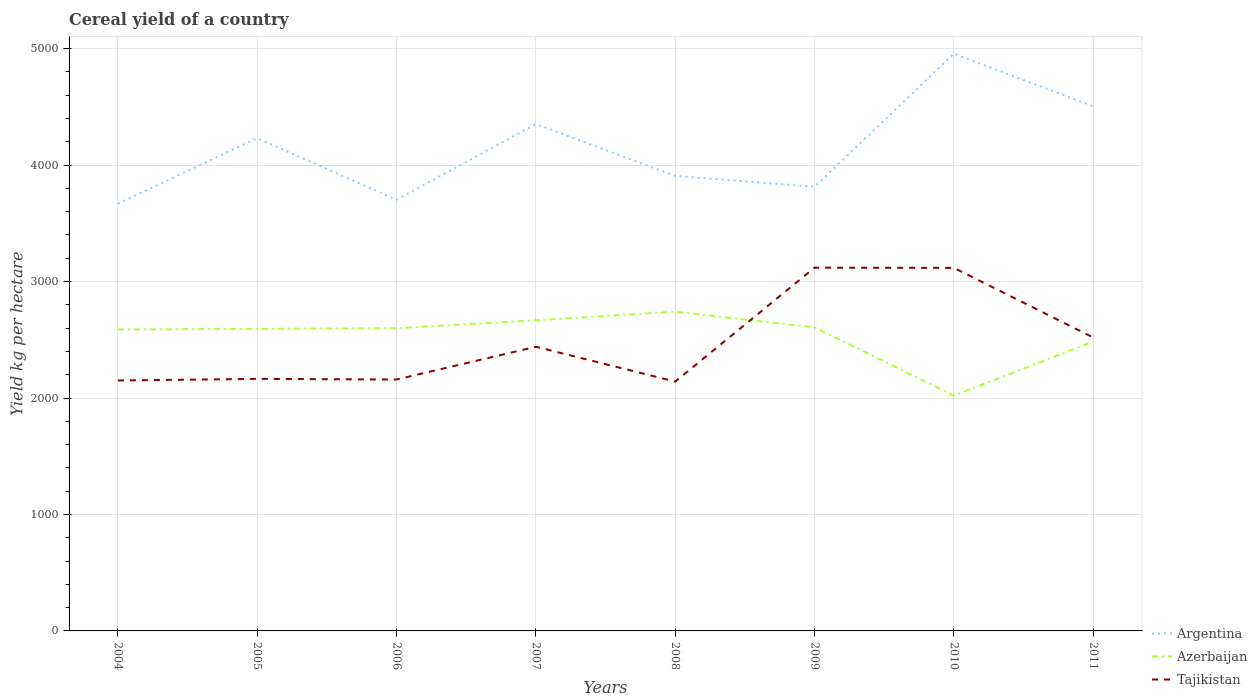How many different coloured lines are there?
Ensure brevity in your answer.  3. Does the line corresponding to Azerbaijan intersect with the line corresponding to Tajikistan?
Keep it short and to the point. Yes. Is the number of lines equal to the number of legend labels?
Your answer should be very brief. Yes. Across all years, what is the maximum total cereal yield in Argentina?
Provide a short and direct response. 3668.39. In which year was the total cereal yield in Argentina maximum?
Provide a short and direct response. 2004. What is the total total cereal yield in Argentina in the graph?
Your answer should be very brief. -649.98. What is the difference between the highest and the second highest total cereal yield in Azerbaijan?
Offer a terse response. 720.84. Are the values on the major ticks of Y-axis written in scientific E-notation?
Your response must be concise. No. Does the graph contain any zero values?
Ensure brevity in your answer.  No. Where does the legend appear in the graph?
Offer a very short reply. Bottom right. How are the legend labels stacked?
Offer a very short reply. Vertical. What is the title of the graph?
Offer a terse response. Cereal yield of a country. Does "Thailand" appear as one of the legend labels in the graph?
Make the answer very short. No. What is the label or title of the X-axis?
Offer a very short reply. Years. What is the label or title of the Y-axis?
Your answer should be compact. Yield kg per hectare. What is the Yield kg per hectare of Argentina in 2004?
Your answer should be very brief. 3668.39. What is the Yield kg per hectare of Azerbaijan in 2004?
Keep it short and to the point. 2588.77. What is the Yield kg per hectare of Tajikistan in 2004?
Make the answer very short. 2150.44. What is the Yield kg per hectare in Argentina in 2005?
Your answer should be very brief. 4231.04. What is the Yield kg per hectare of Azerbaijan in 2005?
Make the answer very short. 2593.13. What is the Yield kg per hectare of Tajikistan in 2005?
Provide a succinct answer. 2164.4. What is the Yield kg per hectare of Argentina in 2006?
Offer a very short reply. 3702.29. What is the Yield kg per hectare of Azerbaijan in 2006?
Make the answer very short. 2599.35. What is the Yield kg per hectare in Tajikistan in 2006?
Offer a very short reply. 2158.71. What is the Yield kg per hectare of Argentina in 2007?
Keep it short and to the point. 4352.27. What is the Yield kg per hectare in Azerbaijan in 2007?
Your response must be concise. 2667.4. What is the Yield kg per hectare of Tajikistan in 2007?
Give a very brief answer. 2440.03. What is the Yield kg per hectare of Argentina in 2008?
Ensure brevity in your answer.  3906.89. What is the Yield kg per hectare in Azerbaijan in 2008?
Give a very brief answer. 2741.48. What is the Yield kg per hectare of Tajikistan in 2008?
Your answer should be compact. 2141.04. What is the Yield kg per hectare of Argentina in 2009?
Give a very brief answer. 3814.31. What is the Yield kg per hectare in Azerbaijan in 2009?
Give a very brief answer. 2606.72. What is the Yield kg per hectare in Tajikistan in 2009?
Your response must be concise. 3119.39. What is the Yield kg per hectare in Argentina in 2010?
Your answer should be compact. 4956.79. What is the Yield kg per hectare in Azerbaijan in 2010?
Your answer should be very brief. 2020.64. What is the Yield kg per hectare of Tajikistan in 2010?
Ensure brevity in your answer.  3117.25. What is the Yield kg per hectare of Argentina in 2011?
Provide a short and direct response. 4504.54. What is the Yield kg per hectare of Azerbaijan in 2011?
Keep it short and to the point. 2484.54. What is the Yield kg per hectare in Tajikistan in 2011?
Provide a succinct answer. 2519.26. Across all years, what is the maximum Yield kg per hectare of Argentina?
Keep it short and to the point. 4956.79. Across all years, what is the maximum Yield kg per hectare of Azerbaijan?
Provide a succinct answer. 2741.48. Across all years, what is the maximum Yield kg per hectare in Tajikistan?
Your answer should be compact. 3119.39. Across all years, what is the minimum Yield kg per hectare in Argentina?
Make the answer very short. 3668.39. Across all years, what is the minimum Yield kg per hectare in Azerbaijan?
Give a very brief answer. 2020.64. Across all years, what is the minimum Yield kg per hectare of Tajikistan?
Your response must be concise. 2141.04. What is the total Yield kg per hectare in Argentina in the graph?
Your answer should be compact. 3.31e+04. What is the total Yield kg per hectare in Azerbaijan in the graph?
Your answer should be compact. 2.03e+04. What is the total Yield kg per hectare of Tajikistan in the graph?
Your answer should be very brief. 1.98e+04. What is the difference between the Yield kg per hectare of Argentina in 2004 and that in 2005?
Give a very brief answer. -562.65. What is the difference between the Yield kg per hectare of Azerbaijan in 2004 and that in 2005?
Your answer should be very brief. -4.36. What is the difference between the Yield kg per hectare of Tajikistan in 2004 and that in 2005?
Keep it short and to the point. -13.96. What is the difference between the Yield kg per hectare in Argentina in 2004 and that in 2006?
Your answer should be compact. -33.9. What is the difference between the Yield kg per hectare in Azerbaijan in 2004 and that in 2006?
Your answer should be compact. -10.57. What is the difference between the Yield kg per hectare in Tajikistan in 2004 and that in 2006?
Make the answer very short. -8.27. What is the difference between the Yield kg per hectare in Argentina in 2004 and that in 2007?
Provide a succinct answer. -683.88. What is the difference between the Yield kg per hectare in Azerbaijan in 2004 and that in 2007?
Make the answer very short. -78.63. What is the difference between the Yield kg per hectare in Tajikistan in 2004 and that in 2007?
Keep it short and to the point. -289.6. What is the difference between the Yield kg per hectare in Argentina in 2004 and that in 2008?
Your answer should be very brief. -238.5. What is the difference between the Yield kg per hectare of Azerbaijan in 2004 and that in 2008?
Your answer should be very brief. -152.7. What is the difference between the Yield kg per hectare in Tajikistan in 2004 and that in 2008?
Provide a short and direct response. 9.4. What is the difference between the Yield kg per hectare in Argentina in 2004 and that in 2009?
Provide a short and direct response. -145.92. What is the difference between the Yield kg per hectare of Azerbaijan in 2004 and that in 2009?
Give a very brief answer. -17.95. What is the difference between the Yield kg per hectare in Tajikistan in 2004 and that in 2009?
Offer a very short reply. -968.95. What is the difference between the Yield kg per hectare of Argentina in 2004 and that in 2010?
Offer a terse response. -1288.4. What is the difference between the Yield kg per hectare in Azerbaijan in 2004 and that in 2010?
Give a very brief answer. 568.14. What is the difference between the Yield kg per hectare of Tajikistan in 2004 and that in 2010?
Your answer should be very brief. -966.81. What is the difference between the Yield kg per hectare of Argentina in 2004 and that in 2011?
Make the answer very short. -836.15. What is the difference between the Yield kg per hectare in Azerbaijan in 2004 and that in 2011?
Make the answer very short. 104.23. What is the difference between the Yield kg per hectare of Tajikistan in 2004 and that in 2011?
Give a very brief answer. -368.83. What is the difference between the Yield kg per hectare in Argentina in 2005 and that in 2006?
Your answer should be very brief. 528.75. What is the difference between the Yield kg per hectare in Azerbaijan in 2005 and that in 2006?
Your answer should be compact. -6.21. What is the difference between the Yield kg per hectare of Tajikistan in 2005 and that in 2006?
Give a very brief answer. 5.69. What is the difference between the Yield kg per hectare of Argentina in 2005 and that in 2007?
Give a very brief answer. -121.23. What is the difference between the Yield kg per hectare in Azerbaijan in 2005 and that in 2007?
Provide a succinct answer. -74.27. What is the difference between the Yield kg per hectare in Tajikistan in 2005 and that in 2007?
Provide a short and direct response. -275.63. What is the difference between the Yield kg per hectare of Argentina in 2005 and that in 2008?
Your answer should be very brief. 324.15. What is the difference between the Yield kg per hectare in Azerbaijan in 2005 and that in 2008?
Your answer should be compact. -148.34. What is the difference between the Yield kg per hectare of Tajikistan in 2005 and that in 2008?
Offer a terse response. 23.36. What is the difference between the Yield kg per hectare of Argentina in 2005 and that in 2009?
Provide a short and direct response. 416.73. What is the difference between the Yield kg per hectare of Azerbaijan in 2005 and that in 2009?
Your answer should be very brief. -13.59. What is the difference between the Yield kg per hectare of Tajikistan in 2005 and that in 2009?
Make the answer very short. -954.99. What is the difference between the Yield kg per hectare in Argentina in 2005 and that in 2010?
Keep it short and to the point. -725.75. What is the difference between the Yield kg per hectare of Azerbaijan in 2005 and that in 2010?
Your response must be concise. 572.5. What is the difference between the Yield kg per hectare of Tajikistan in 2005 and that in 2010?
Your answer should be very brief. -952.85. What is the difference between the Yield kg per hectare of Argentina in 2005 and that in 2011?
Provide a succinct answer. -273.5. What is the difference between the Yield kg per hectare of Azerbaijan in 2005 and that in 2011?
Ensure brevity in your answer.  108.59. What is the difference between the Yield kg per hectare of Tajikistan in 2005 and that in 2011?
Keep it short and to the point. -354.87. What is the difference between the Yield kg per hectare in Argentina in 2006 and that in 2007?
Provide a succinct answer. -649.98. What is the difference between the Yield kg per hectare of Azerbaijan in 2006 and that in 2007?
Provide a short and direct response. -68.06. What is the difference between the Yield kg per hectare in Tajikistan in 2006 and that in 2007?
Your answer should be compact. -281.32. What is the difference between the Yield kg per hectare of Argentina in 2006 and that in 2008?
Your answer should be compact. -204.6. What is the difference between the Yield kg per hectare of Azerbaijan in 2006 and that in 2008?
Provide a succinct answer. -142.13. What is the difference between the Yield kg per hectare in Tajikistan in 2006 and that in 2008?
Your answer should be very brief. 17.67. What is the difference between the Yield kg per hectare of Argentina in 2006 and that in 2009?
Provide a short and direct response. -112.02. What is the difference between the Yield kg per hectare in Azerbaijan in 2006 and that in 2009?
Your answer should be compact. -7.37. What is the difference between the Yield kg per hectare of Tajikistan in 2006 and that in 2009?
Offer a very short reply. -960.68. What is the difference between the Yield kg per hectare of Argentina in 2006 and that in 2010?
Provide a short and direct response. -1254.5. What is the difference between the Yield kg per hectare of Azerbaijan in 2006 and that in 2010?
Provide a short and direct response. 578.71. What is the difference between the Yield kg per hectare in Tajikistan in 2006 and that in 2010?
Provide a succinct answer. -958.54. What is the difference between the Yield kg per hectare of Argentina in 2006 and that in 2011?
Offer a terse response. -802.25. What is the difference between the Yield kg per hectare in Azerbaijan in 2006 and that in 2011?
Provide a short and direct response. 114.81. What is the difference between the Yield kg per hectare of Tajikistan in 2006 and that in 2011?
Make the answer very short. -360.56. What is the difference between the Yield kg per hectare of Argentina in 2007 and that in 2008?
Keep it short and to the point. 445.38. What is the difference between the Yield kg per hectare of Azerbaijan in 2007 and that in 2008?
Give a very brief answer. -74.08. What is the difference between the Yield kg per hectare of Tajikistan in 2007 and that in 2008?
Make the answer very short. 298.99. What is the difference between the Yield kg per hectare of Argentina in 2007 and that in 2009?
Offer a terse response. 537.96. What is the difference between the Yield kg per hectare of Azerbaijan in 2007 and that in 2009?
Provide a succinct answer. 60.68. What is the difference between the Yield kg per hectare in Tajikistan in 2007 and that in 2009?
Provide a succinct answer. -679.36. What is the difference between the Yield kg per hectare of Argentina in 2007 and that in 2010?
Provide a short and direct response. -604.52. What is the difference between the Yield kg per hectare in Azerbaijan in 2007 and that in 2010?
Your answer should be very brief. 646.77. What is the difference between the Yield kg per hectare of Tajikistan in 2007 and that in 2010?
Offer a very short reply. -677.22. What is the difference between the Yield kg per hectare of Argentina in 2007 and that in 2011?
Offer a terse response. -152.28. What is the difference between the Yield kg per hectare in Azerbaijan in 2007 and that in 2011?
Your answer should be compact. 182.86. What is the difference between the Yield kg per hectare of Tajikistan in 2007 and that in 2011?
Provide a short and direct response. -79.23. What is the difference between the Yield kg per hectare in Argentina in 2008 and that in 2009?
Give a very brief answer. 92.58. What is the difference between the Yield kg per hectare in Azerbaijan in 2008 and that in 2009?
Make the answer very short. 134.76. What is the difference between the Yield kg per hectare in Tajikistan in 2008 and that in 2009?
Make the answer very short. -978.35. What is the difference between the Yield kg per hectare in Argentina in 2008 and that in 2010?
Offer a very short reply. -1049.9. What is the difference between the Yield kg per hectare of Azerbaijan in 2008 and that in 2010?
Provide a short and direct response. 720.84. What is the difference between the Yield kg per hectare in Tajikistan in 2008 and that in 2010?
Keep it short and to the point. -976.21. What is the difference between the Yield kg per hectare in Argentina in 2008 and that in 2011?
Your response must be concise. -597.65. What is the difference between the Yield kg per hectare of Azerbaijan in 2008 and that in 2011?
Provide a succinct answer. 256.94. What is the difference between the Yield kg per hectare in Tajikistan in 2008 and that in 2011?
Keep it short and to the point. -378.23. What is the difference between the Yield kg per hectare in Argentina in 2009 and that in 2010?
Give a very brief answer. -1142.48. What is the difference between the Yield kg per hectare in Azerbaijan in 2009 and that in 2010?
Offer a very short reply. 586.08. What is the difference between the Yield kg per hectare of Tajikistan in 2009 and that in 2010?
Your response must be concise. 2.14. What is the difference between the Yield kg per hectare of Argentina in 2009 and that in 2011?
Provide a succinct answer. -690.23. What is the difference between the Yield kg per hectare in Azerbaijan in 2009 and that in 2011?
Offer a very short reply. 122.18. What is the difference between the Yield kg per hectare of Tajikistan in 2009 and that in 2011?
Keep it short and to the point. 600.12. What is the difference between the Yield kg per hectare of Argentina in 2010 and that in 2011?
Your answer should be very brief. 452.25. What is the difference between the Yield kg per hectare in Azerbaijan in 2010 and that in 2011?
Make the answer very short. -463.9. What is the difference between the Yield kg per hectare of Tajikistan in 2010 and that in 2011?
Your response must be concise. 597.98. What is the difference between the Yield kg per hectare of Argentina in 2004 and the Yield kg per hectare of Azerbaijan in 2005?
Offer a very short reply. 1075.26. What is the difference between the Yield kg per hectare in Argentina in 2004 and the Yield kg per hectare in Tajikistan in 2005?
Give a very brief answer. 1503.99. What is the difference between the Yield kg per hectare in Azerbaijan in 2004 and the Yield kg per hectare in Tajikistan in 2005?
Keep it short and to the point. 424.37. What is the difference between the Yield kg per hectare of Argentina in 2004 and the Yield kg per hectare of Azerbaijan in 2006?
Provide a succinct answer. 1069.04. What is the difference between the Yield kg per hectare of Argentina in 2004 and the Yield kg per hectare of Tajikistan in 2006?
Make the answer very short. 1509.68. What is the difference between the Yield kg per hectare in Azerbaijan in 2004 and the Yield kg per hectare in Tajikistan in 2006?
Your answer should be compact. 430.07. What is the difference between the Yield kg per hectare of Argentina in 2004 and the Yield kg per hectare of Azerbaijan in 2007?
Provide a succinct answer. 1000.99. What is the difference between the Yield kg per hectare of Argentina in 2004 and the Yield kg per hectare of Tajikistan in 2007?
Your response must be concise. 1228.36. What is the difference between the Yield kg per hectare of Azerbaijan in 2004 and the Yield kg per hectare of Tajikistan in 2007?
Your answer should be compact. 148.74. What is the difference between the Yield kg per hectare in Argentina in 2004 and the Yield kg per hectare in Azerbaijan in 2008?
Keep it short and to the point. 926.91. What is the difference between the Yield kg per hectare in Argentina in 2004 and the Yield kg per hectare in Tajikistan in 2008?
Your answer should be very brief. 1527.35. What is the difference between the Yield kg per hectare of Azerbaijan in 2004 and the Yield kg per hectare of Tajikistan in 2008?
Make the answer very short. 447.74. What is the difference between the Yield kg per hectare in Argentina in 2004 and the Yield kg per hectare in Azerbaijan in 2009?
Offer a terse response. 1061.67. What is the difference between the Yield kg per hectare in Argentina in 2004 and the Yield kg per hectare in Tajikistan in 2009?
Offer a very short reply. 549. What is the difference between the Yield kg per hectare of Azerbaijan in 2004 and the Yield kg per hectare of Tajikistan in 2009?
Provide a short and direct response. -530.61. What is the difference between the Yield kg per hectare in Argentina in 2004 and the Yield kg per hectare in Azerbaijan in 2010?
Offer a very short reply. 1647.75. What is the difference between the Yield kg per hectare of Argentina in 2004 and the Yield kg per hectare of Tajikistan in 2010?
Make the answer very short. 551.14. What is the difference between the Yield kg per hectare of Azerbaijan in 2004 and the Yield kg per hectare of Tajikistan in 2010?
Provide a succinct answer. -528.47. What is the difference between the Yield kg per hectare of Argentina in 2004 and the Yield kg per hectare of Azerbaijan in 2011?
Your answer should be compact. 1183.85. What is the difference between the Yield kg per hectare in Argentina in 2004 and the Yield kg per hectare in Tajikistan in 2011?
Provide a short and direct response. 1149.12. What is the difference between the Yield kg per hectare of Azerbaijan in 2004 and the Yield kg per hectare of Tajikistan in 2011?
Keep it short and to the point. 69.51. What is the difference between the Yield kg per hectare of Argentina in 2005 and the Yield kg per hectare of Azerbaijan in 2006?
Provide a short and direct response. 1631.69. What is the difference between the Yield kg per hectare of Argentina in 2005 and the Yield kg per hectare of Tajikistan in 2006?
Make the answer very short. 2072.33. What is the difference between the Yield kg per hectare of Azerbaijan in 2005 and the Yield kg per hectare of Tajikistan in 2006?
Ensure brevity in your answer.  434.43. What is the difference between the Yield kg per hectare of Argentina in 2005 and the Yield kg per hectare of Azerbaijan in 2007?
Your response must be concise. 1563.64. What is the difference between the Yield kg per hectare of Argentina in 2005 and the Yield kg per hectare of Tajikistan in 2007?
Provide a short and direct response. 1791.01. What is the difference between the Yield kg per hectare of Azerbaijan in 2005 and the Yield kg per hectare of Tajikistan in 2007?
Provide a short and direct response. 153.1. What is the difference between the Yield kg per hectare in Argentina in 2005 and the Yield kg per hectare in Azerbaijan in 2008?
Offer a very short reply. 1489.56. What is the difference between the Yield kg per hectare in Argentina in 2005 and the Yield kg per hectare in Tajikistan in 2008?
Give a very brief answer. 2090. What is the difference between the Yield kg per hectare of Azerbaijan in 2005 and the Yield kg per hectare of Tajikistan in 2008?
Provide a short and direct response. 452.1. What is the difference between the Yield kg per hectare of Argentina in 2005 and the Yield kg per hectare of Azerbaijan in 2009?
Your answer should be compact. 1624.32. What is the difference between the Yield kg per hectare in Argentina in 2005 and the Yield kg per hectare in Tajikistan in 2009?
Offer a terse response. 1111.65. What is the difference between the Yield kg per hectare of Azerbaijan in 2005 and the Yield kg per hectare of Tajikistan in 2009?
Ensure brevity in your answer.  -526.25. What is the difference between the Yield kg per hectare of Argentina in 2005 and the Yield kg per hectare of Azerbaijan in 2010?
Give a very brief answer. 2210.4. What is the difference between the Yield kg per hectare in Argentina in 2005 and the Yield kg per hectare in Tajikistan in 2010?
Make the answer very short. 1113.79. What is the difference between the Yield kg per hectare of Azerbaijan in 2005 and the Yield kg per hectare of Tajikistan in 2010?
Offer a very short reply. -524.11. What is the difference between the Yield kg per hectare in Argentina in 2005 and the Yield kg per hectare in Azerbaijan in 2011?
Offer a very short reply. 1746.5. What is the difference between the Yield kg per hectare in Argentina in 2005 and the Yield kg per hectare in Tajikistan in 2011?
Your answer should be compact. 1711.77. What is the difference between the Yield kg per hectare of Azerbaijan in 2005 and the Yield kg per hectare of Tajikistan in 2011?
Keep it short and to the point. 73.87. What is the difference between the Yield kg per hectare of Argentina in 2006 and the Yield kg per hectare of Azerbaijan in 2007?
Your answer should be compact. 1034.88. What is the difference between the Yield kg per hectare of Argentina in 2006 and the Yield kg per hectare of Tajikistan in 2007?
Your answer should be very brief. 1262.26. What is the difference between the Yield kg per hectare in Azerbaijan in 2006 and the Yield kg per hectare in Tajikistan in 2007?
Provide a succinct answer. 159.32. What is the difference between the Yield kg per hectare in Argentina in 2006 and the Yield kg per hectare in Azerbaijan in 2008?
Make the answer very short. 960.81. What is the difference between the Yield kg per hectare of Argentina in 2006 and the Yield kg per hectare of Tajikistan in 2008?
Your answer should be very brief. 1561.25. What is the difference between the Yield kg per hectare of Azerbaijan in 2006 and the Yield kg per hectare of Tajikistan in 2008?
Your answer should be compact. 458.31. What is the difference between the Yield kg per hectare of Argentina in 2006 and the Yield kg per hectare of Azerbaijan in 2009?
Give a very brief answer. 1095.57. What is the difference between the Yield kg per hectare in Argentina in 2006 and the Yield kg per hectare in Tajikistan in 2009?
Give a very brief answer. 582.9. What is the difference between the Yield kg per hectare of Azerbaijan in 2006 and the Yield kg per hectare of Tajikistan in 2009?
Provide a succinct answer. -520.04. What is the difference between the Yield kg per hectare in Argentina in 2006 and the Yield kg per hectare in Azerbaijan in 2010?
Keep it short and to the point. 1681.65. What is the difference between the Yield kg per hectare in Argentina in 2006 and the Yield kg per hectare in Tajikistan in 2010?
Make the answer very short. 585.04. What is the difference between the Yield kg per hectare in Azerbaijan in 2006 and the Yield kg per hectare in Tajikistan in 2010?
Your answer should be very brief. -517.9. What is the difference between the Yield kg per hectare in Argentina in 2006 and the Yield kg per hectare in Azerbaijan in 2011?
Offer a terse response. 1217.75. What is the difference between the Yield kg per hectare in Argentina in 2006 and the Yield kg per hectare in Tajikistan in 2011?
Offer a very short reply. 1183.02. What is the difference between the Yield kg per hectare in Azerbaijan in 2006 and the Yield kg per hectare in Tajikistan in 2011?
Your response must be concise. 80.08. What is the difference between the Yield kg per hectare in Argentina in 2007 and the Yield kg per hectare in Azerbaijan in 2008?
Provide a succinct answer. 1610.79. What is the difference between the Yield kg per hectare in Argentina in 2007 and the Yield kg per hectare in Tajikistan in 2008?
Offer a very short reply. 2211.23. What is the difference between the Yield kg per hectare of Azerbaijan in 2007 and the Yield kg per hectare of Tajikistan in 2008?
Your answer should be compact. 526.37. What is the difference between the Yield kg per hectare in Argentina in 2007 and the Yield kg per hectare in Azerbaijan in 2009?
Your answer should be very brief. 1745.55. What is the difference between the Yield kg per hectare in Argentina in 2007 and the Yield kg per hectare in Tajikistan in 2009?
Provide a short and direct response. 1232.88. What is the difference between the Yield kg per hectare of Azerbaijan in 2007 and the Yield kg per hectare of Tajikistan in 2009?
Your response must be concise. -451.98. What is the difference between the Yield kg per hectare in Argentina in 2007 and the Yield kg per hectare in Azerbaijan in 2010?
Provide a short and direct response. 2331.63. What is the difference between the Yield kg per hectare in Argentina in 2007 and the Yield kg per hectare in Tajikistan in 2010?
Ensure brevity in your answer.  1235.02. What is the difference between the Yield kg per hectare in Azerbaijan in 2007 and the Yield kg per hectare in Tajikistan in 2010?
Provide a succinct answer. -449.84. What is the difference between the Yield kg per hectare in Argentina in 2007 and the Yield kg per hectare in Azerbaijan in 2011?
Provide a short and direct response. 1867.72. What is the difference between the Yield kg per hectare in Argentina in 2007 and the Yield kg per hectare in Tajikistan in 2011?
Ensure brevity in your answer.  1833. What is the difference between the Yield kg per hectare of Azerbaijan in 2007 and the Yield kg per hectare of Tajikistan in 2011?
Offer a very short reply. 148.14. What is the difference between the Yield kg per hectare in Argentina in 2008 and the Yield kg per hectare in Azerbaijan in 2009?
Your answer should be very brief. 1300.17. What is the difference between the Yield kg per hectare of Argentina in 2008 and the Yield kg per hectare of Tajikistan in 2009?
Provide a short and direct response. 787.5. What is the difference between the Yield kg per hectare of Azerbaijan in 2008 and the Yield kg per hectare of Tajikistan in 2009?
Provide a succinct answer. -377.91. What is the difference between the Yield kg per hectare in Argentina in 2008 and the Yield kg per hectare in Azerbaijan in 2010?
Keep it short and to the point. 1886.25. What is the difference between the Yield kg per hectare in Argentina in 2008 and the Yield kg per hectare in Tajikistan in 2010?
Offer a very short reply. 789.64. What is the difference between the Yield kg per hectare of Azerbaijan in 2008 and the Yield kg per hectare of Tajikistan in 2010?
Your answer should be very brief. -375.77. What is the difference between the Yield kg per hectare in Argentina in 2008 and the Yield kg per hectare in Azerbaijan in 2011?
Make the answer very short. 1422.35. What is the difference between the Yield kg per hectare in Argentina in 2008 and the Yield kg per hectare in Tajikistan in 2011?
Keep it short and to the point. 1387.62. What is the difference between the Yield kg per hectare in Azerbaijan in 2008 and the Yield kg per hectare in Tajikistan in 2011?
Make the answer very short. 222.21. What is the difference between the Yield kg per hectare of Argentina in 2009 and the Yield kg per hectare of Azerbaijan in 2010?
Provide a short and direct response. 1793.67. What is the difference between the Yield kg per hectare of Argentina in 2009 and the Yield kg per hectare of Tajikistan in 2010?
Your response must be concise. 697.06. What is the difference between the Yield kg per hectare of Azerbaijan in 2009 and the Yield kg per hectare of Tajikistan in 2010?
Your answer should be compact. -510.53. What is the difference between the Yield kg per hectare of Argentina in 2009 and the Yield kg per hectare of Azerbaijan in 2011?
Your response must be concise. 1329.77. What is the difference between the Yield kg per hectare in Argentina in 2009 and the Yield kg per hectare in Tajikistan in 2011?
Give a very brief answer. 1295.04. What is the difference between the Yield kg per hectare in Azerbaijan in 2009 and the Yield kg per hectare in Tajikistan in 2011?
Offer a terse response. 87.46. What is the difference between the Yield kg per hectare in Argentina in 2010 and the Yield kg per hectare in Azerbaijan in 2011?
Ensure brevity in your answer.  2472.25. What is the difference between the Yield kg per hectare in Argentina in 2010 and the Yield kg per hectare in Tajikistan in 2011?
Ensure brevity in your answer.  2437.53. What is the difference between the Yield kg per hectare of Azerbaijan in 2010 and the Yield kg per hectare of Tajikistan in 2011?
Offer a terse response. -498.63. What is the average Yield kg per hectare of Argentina per year?
Make the answer very short. 4142.06. What is the average Yield kg per hectare in Azerbaijan per year?
Provide a succinct answer. 2537.75. What is the average Yield kg per hectare in Tajikistan per year?
Offer a terse response. 2476.31. In the year 2004, what is the difference between the Yield kg per hectare of Argentina and Yield kg per hectare of Azerbaijan?
Your answer should be compact. 1079.62. In the year 2004, what is the difference between the Yield kg per hectare of Argentina and Yield kg per hectare of Tajikistan?
Your answer should be compact. 1517.95. In the year 2004, what is the difference between the Yield kg per hectare in Azerbaijan and Yield kg per hectare in Tajikistan?
Your answer should be compact. 438.34. In the year 2005, what is the difference between the Yield kg per hectare of Argentina and Yield kg per hectare of Azerbaijan?
Make the answer very short. 1637.91. In the year 2005, what is the difference between the Yield kg per hectare of Argentina and Yield kg per hectare of Tajikistan?
Provide a succinct answer. 2066.64. In the year 2005, what is the difference between the Yield kg per hectare in Azerbaijan and Yield kg per hectare in Tajikistan?
Your answer should be very brief. 428.73. In the year 2006, what is the difference between the Yield kg per hectare of Argentina and Yield kg per hectare of Azerbaijan?
Offer a very short reply. 1102.94. In the year 2006, what is the difference between the Yield kg per hectare of Argentina and Yield kg per hectare of Tajikistan?
Give a very brief answer. 1543.58. In the year 2006, what is the difference between the Yield kg per hectare of Azerbaijan and Yield kg per hectare of Tajikistan?
Keep it short and to the point. 440.64. In the year 2007, what is the difference between the Yield kg per hectare in Argentina and Yield kg per hectare in Azerbaijan?
Offer a very short reply. 1684.86. In the year 2007, what is the difference between the Yield kg per hectare of Argentina and Yield kg per hectare of Tajikistan?
Ensure brevity in your answer.  1912.24. In the year 2007, what is the difference between the Yield kg per hectare in Azerbaijan and Yield kg per hectare in Tajikistan?
Your response must be concise. 227.37. In the year 2008, what is the difference between the Yield kg per hectare in Argentina and Yield kg per hectare in Azerbaijan?
Provide a short and direct response. 1165.41. In the year 2008, what is the difference between the Yield kg per hectare in Argentina and Yield kg per hectare in Tajikistan?
Your response must be concise. 1765.85. In the year 2008, what is the difference between the Yield kg per hectare in Azerbaijan and Yield kg per hectare in Tajikistan?
Ensure brevity in your answer.  600.44. In the year 2009, what is the difference between the Yield kg per hectare in Argentina and Yield kg per hectare in Azerbaijan?
Offer a terse response. 1207.59. In the year 2009, what is the difference between the Yield kg per hectare of Argentina and Yield kg per hectare of Tajikistan?
Make the answer very short. 694.92. In the year 2009, what is the difference between the Yield kg per hectare of Azerbaijan and Yield kg per hectare of Tajikistan?
Give a very brief answer. -512.66. In the year 2010, what is the difference between the Yield kg per hectare of Argentina and Yield kg per hectare of Azerbaijan?
Ensure brevity in your answer.  2936.16. In the year 2010, what is the difference between the Yield kg per hectare in Argentina and Yield kg per hectare in Tajikistan?
Your answer should be compact. 1839.55. In the year 2010, what is the difference between the Yield kg per hectare of Azerbaijan and Yield kg per hectare of Tajikistan?
Provide a succinct answer. -1096.61. In the year 2011, what is the difference between the Yield kg per hectare in Argentina and Yield kg per hectare in Azerbaijan?
Your answer should be very brief. 2020. In the year 2011, what is the difference between the Yield kg per hectare in Argentina and Yield kg per hectare in Tajikistan?
Provide a succinct answer. 1985.28. In the year 2011, what is the difference between the Yield kg per hectare in Azerbaijan and Yield kg per hectare in Tajikistan?
Provide a short and direct response. -34.72. What is the ratio of the Yield kg per hectare in Argentina in 2004 to that in 2005?
Provide a succinct answer. 0.87. What is the ratio of the Yield kg per hectare of Azerbaijan in 2004 to that in 2005?
Make the answer very short. 1. What is the ratio of the Yield kg per hectare of Tajikistan in 2004 to that in 2005?
Offer a terse response. 0.99. What is the ratio of the Yield kg per hectare in Argentina in 2004 to that in 2006?
Make the answer very short. 0.99. What is the ratio of the Yield kg per hectare in Tajikistan in 2004 to that in 2006?
Provide a succinct answer. 1. What is the ratio of the Yield kg per hectare in Argentina in 2004 to that in 2007?
Give a very brief answer. 0.84. What is the ratio of the Yield kg per hectare in Azerbaijan in 2004 to that in 2007?
Your answer should be compact. 0.97. What is the ratio of the Yield kg per hectare in Tajikistan in 2004 to that in 2007?
Keep it short and to the point. 0.88. What is the ratio of the Yield kg per hectare of Argentina in 2004 to that in 2008?
Offer a very short reply. 0.94. What is the ratio of the Yield kg per hectare of Azerbaijan in 2004 to that in 2008?
Give a very brief answer. 0.94. What is the ratio of the Yield kg per hectare of Tajikistan in 2004 to that in 2008?
Offer a terse response. 1. What is the ratio of the Yield kg per hectare in Argentina in 2004 to that in 2009?
Make the answer very short. 0.96. What is the ratio of the Yield kg per hectare of Azerbaijan in 2004 to that in 2009?
Make the answer very short. 0.99. What is the ratio of the Yield kg per hectare of Tajikistan in 2004 to that in 2009?
Offer a terse response. 0.69. What is the ratio of the Yield kg per hectare of Argentina in 2004 to that in 2010?
Your answer should be very brief. 0.74. What is the ratio of the Yield kg per hectare of Azerbaijan in 2004 to that in 2010?
Offer a terse response. 1.28. What is the ratio of the Yield kg per hectare of Tajikistan in 2004 to that in 2010?
Provide a succinct answer. 0.69. What is the ratio of the Yield kg per hectare in Argentina in 2004 to that in 2011?
Provide a succinct answer. 0.81. What is the ratio of the Yield kg per hectare of Azerbaijan in 2004 to that in 2011?
Give a very brief answer. 1.04. What is the ratio of the Yield kg per hectare in Tajikistan in 2004 to that in 2011?
Your response must be concise. 0.85. What is the ratio of the Yield kg per hectare in Argentina in 2005 to that in 2006?
Give a very brief answer. 1.14. What is the ratio of the Yield kg per hectare of Argentina in 2005 to that in 2007?
Your answer should be very brief. 0.97. What is the ratio of the Yield kg per hectare in Azerbaijan in 2005 to that in 2007?
Make the answer very short. 0.97. What is the ratio of the Yield kg per hectare of Tajikistan in 2005 to that in 2007?
Ensure brevity in your answer.  0.89. What is the ratio of the Yield kg per hectare in Argentina in 2005 to that in 2008?
Give a very brief answer. 1.08. What is the ratio of the Yield kg per hectare of Azerbaijan in 2005 to that in 2008?
Provide a short and direct response. 0.95. What is the ratio of the Yield kg per hectare of Tajikistan in 2005 to that in 2008?
Give a very brief answer. 1.01. What is the ratio of the Yield kg per hectare of Argentina in 2005 to that in 2009?
Provide a succinct answer. 1.11. What is the ratio of the Yield kg per hectare in Tajikistan in 2005 to that in 2009?
Provide a succinct answer. 0.69. What is the ratio of the Yield kg per hectare of Argentina in 2005 to that in 2010?
Give a very brief answer. 0.85. What is the ratio of the Yield kg per hectare of Azerbaijan in 2005 to that in 2010?
Provide a short and direct response. 1.28. What is the ratio of the Yield kg per hectare in Tajikistan in 2005 to that in 2010?
Give a very brief answer. 0.69. What is the ratio of the Yield kg per hectare in Argentina in 2005 to that in 2011?
Your response must be concise. 0.94. What is the ratio of the Yield kg per hectare of Azerbaijan in 2005 to that in 2011?
Keep it short and to the point. 1.04. What is the ratio of the Yield kg per hectare of Tajikistan in 2005 to that in 2011?
Provide a short and direct response. 0.86. What is the ratio of the Yield kg per hectare of Argentina in 2006 to that in 2007?
Your answer should be very brief. 0.85. What is the ratio of the Yield kg per hectare of Azerbaijan in 2006 to that in 2007?
Give a very brief answer. 0.97. What is the ratio of the Yield kg per hectare in Tajikistan in 2006 to that in 2007?
Your answer should be very brief. 0.88. What is the ratio of the Yield kg per hectare of Argentina in 2006 to that in 2008?
Offer a terse response. 0.95. What is the ratio of the Yield kg per hectare of Azerbaijan in 2006 to that in 2008?
Provide a succinct answer. 0.95. What is the ratio of the Yield kg per hectare in Tajikistan in 2006 to that in 2008?
Make the answer very short. 1.01. What is the ratio of the Yield kg per hectare in Argentina in 2006 to that in 2009?
Your answer should be compact. 0.97. What is the ratio of the Yield kg per hectare in Azerbaijan in 2006 to that in 2009?
Keep it short and to the point. 1. What is the ratio of the Yield kg per hectare in Tajikistan in 2006 to that in 2009?
Make the answer very short. 0.69. What is the ratio of the Yield kg per hectare in Argentina in 2006 to that in 2010?
Keep it short and to the point. 0.75. What is the ratio of the Yield kg per hectare in Azerbaijan in 2006 to that in 2010?
Your answer should be compact. 1.29. What is the ratio of the Yield kg per hectare of Tajikistan in 2006 to that in 2010?
Make the answer very short. 0.69. What is the ratio of the Yield kg per hectare in Argentina in 2006 to that in 2011?
Offer a very short reply. 0.82. What is the ratio of the Yield kg per hectare in Azerbaijan in 2006 to that in 2011?
Your answer should be compact. 1.05. What is the ratio of the Yield kg per hectare of Tajikistan in 2006 to that in 2011?
Offer a terse response. 0.86. What is the ratio of the Yield kg per hectare in Argentina in 2007 to that in 2008?
Make the answer very short. 1.11. What is the ratio of the Yield kg per hectare in Tajikistan in 2007 to that in 2008?
Provide a short and direct response. 1.14. What is the ratio of the Yield kg per hectare in Argentina in 2007 to that in 2009?
Give a very brief answer. 1.14. What is the ratio of the Yield kg per hectare in Azerbaijan in 2007 to that in 2009?
Provide a short and direct response. 1.02. What is the ratio of the Yield kg per hectare in Tajikistan in 2007 to that in 2009?
Give a very brief answer. 0.78. What is the ratio of the Yield kg per hectare in Argentina in 2007 to that in 2010?
Your answer should be compact. 0.88. What is the ratio of the Yield kg per hectare of Azerbaijan in 2007 to that in 2010?
Provide a short and direct response. 1.32. What is the ratio of the Yield kg per hectare of Tajikistan in 2007 to that in 2010?
Your response must be concise. 0.78. What is the ratio of the Yield kg per hectare of Argentina in 2007 to that in 2011?
Your answer should be very brief. 0.97. What is the ratio of the Yield kg per hectare in Azerbaijan in 2007 to that in 2011?
Give a very brief answer. 1.07. What is the ratio of the Yield kg per hectare of Tajikistan in 2007 to that in 2011?
Give a very brief answer. 0.97. What is the ratio of the Yield kg per hectare of Argentina in 2008 to that in 2009?
Provide a short and direct response. 1.02. What is the ratio of the Yield kg per hectare of Azerbaijan in 2008 to that in 2009?
Ensure brevity in your answer.  1.05. What is the ratio of the Yield kg per hectare in Tajikistan in 2008 to that in 2009?
Ensure brevity in your answer.  0.69. What is the ratio of the Yield kg per hectare of Argentina in 2008 to that in 2010?
Keep it short and to the point. 0.79. What is the ratio of the Yield kg per hectare of Azerbaijan in 2008 to that in 2010?
Ensure brevity in your answer.  1.36. What is the ratio of the Yield kg per hectare of Tajikistan in 2008 to that in 2010?
Provide a short and direct response. 0.69. What is the ratio of the Yield kg per hectare of Argentina in 2008 to that in 2011?
Give a very brief answer. 0.87. What is the ratio of the Yield kg per hectare in Azerbaijan in 2008 to that in 2011?
Your response must be concise. 1.1. What is the ratio of the Yield kg per hectare of Tajikistan in 2008 to that in 2011?
Make the answer very short. 0.85. What is the ratio of the Yield kg per hectare of Argentina in 2009 to that in 2010?
Keep it short and to the point. 0.77. What is the ratio of the Yield kg per hectare in Azerbaijan in 2009 to that in 2010?
Make the answer very short. 1.29. What is the ratio of the Yield kg per hectare of Tajikistan in 2009 to that in 2010?
Give a very brief answer. 1. What is the ratio of the Yield kg per hectare in Argentina in 2009 to that in 2011?
Your answer should be very brief. 0.85. What is the ratio of the Yield kg per hectare of Azerbaijan in 2009 to that in 2011?
Your answer should be compact. 1.05. What is the ratio of the Yield kg per hectare in Tajikistan in 2009 to that in 2011?
Ensure brevity in your answer.  1.24. What is the ratio of the Yield kg per hectare of Argentina in 2010 to that in 2011?
Your response must be concise. 1.1. What is the ratio of the Yield kg per hectare of Azerbaijan in 2010 to that in 2011?
Your answer should be very brief. 0.81. What is the ratio of the Yield kg per hectare of Tajikistan in 2010 to that in 2011?
Your answer should be very brief. 1.24. What is the difference between the highest and the second highest Yield kg per hectare of Argentina?
Give a very brief answer. 452.25. What is the difference between the highest and the second highest Yield kg per hectare in Azerbaijan?
Ensure brevity in your answer.  74.08. What is the difference between the highest and the second highest Yield kg per hectare of Tajikistan?
Offer a terse response. 2.14. What is the difference between the highest and the lowest Yield kg per hectare in Argentina?
Ensure brevity in your answer.  1288.4. What is the difference between the highest and the lowest Yield kg per hectare of Azerbaijan?
Ensure brevity in your answer.  720.84. What is the difference between the highest and the lowest Yield kg per hectare of Tajikistan?
Keep it short and to the point. 978.35. 